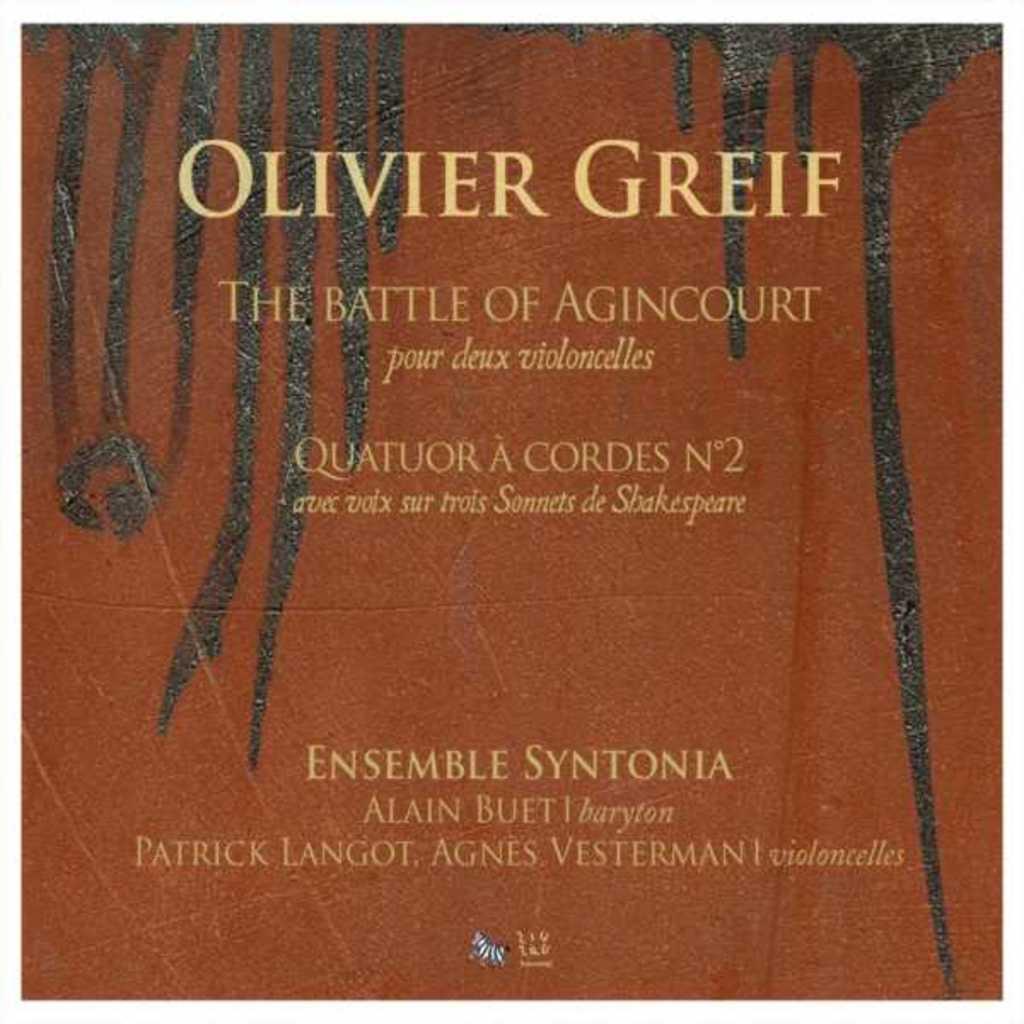What battle is this?
Your response must be concise. Agincourt. 